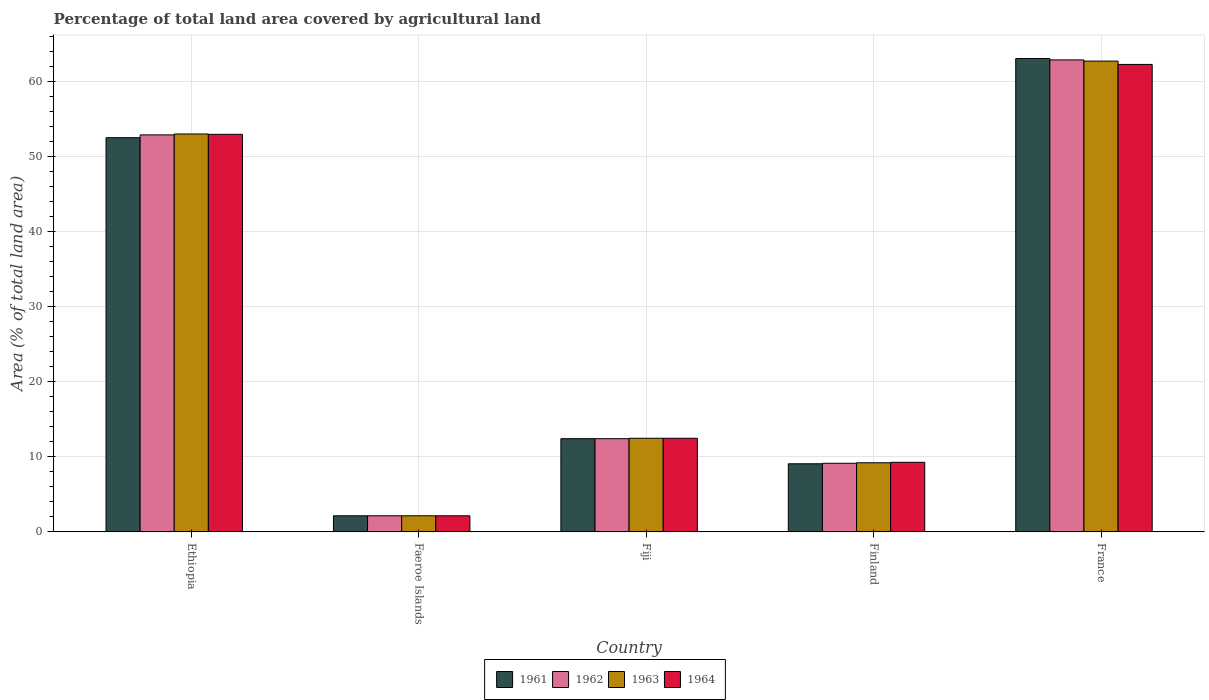How many different coloured bars are there?
Your response must be concise. 4. Are the number of bars per tick equal to the number of legend labels?
Provide a short and direct response. Yes. Are the number of bars on each tick of the X-axis equal?
Provide a short and direct response. Yes. How many bars are there on the 3rd tick from the right?
Provide a short and direct response. 4. What is the label of the 2nd group of bars from the left?
Make the answer very short. Faeroe Islands. What is the percentage of agricultural land in 1961 in Fiji?
Make the answer very short. 12.42. Across all countries, what is the maximum percentage of agricultural land in 1962?
Make the answer very short. 62.9. Across all countries, what is the minimum percentage of agricultural land in 1962?
Ensure brevity in your answer.  2.15. In which country was the percentage of agricultural land in 1963 minimum?
Give a very brief answer. Faeroe Islands. What is the total percentage of agricultural land in 1961 in the graph?
Your answer should be compact. 139.26. What is the difference between the percentage of agricultural land in 1963 in Faeroe Islands and that in Fiji?
Ensure brevity in your answer.  -10.33. What is the difference between the percentage of agricultural land in 1962 in Fiji and the percentage of agricultural land in 1961 in Faeroe Islands?
Give a very brief answer. 10.28. What is the average percentage of agricultural land in 1961 per country?
Ensure brevity in your answer.  27.85. What is the difference between the percentage of agricultural land of/in 1963 and percentage of agricultural land of/in 1964 in Fiji?
Provide a short and direct response. 0. In how many countries, is the percentage of agricultural land in 1963 greater than 46 %?
Provide a short and direct response. 2. What is the ratio of the percentage of agricultural land in 1962 in Faeroe Islands to that in Finland?
Provide a succinct answer. 0.24. Is the percentage of agricultural land in 1963 in Ethiopia less than that in France?
Offer a very short reply. Yes. What is the difference between the highest and the second highest percentage of agricultural land in 1961?
Keep it short and to the point. 40.11. What is the difference between the highest and the lowest percentage of agricultural land in 1964?
Your answer should be very brief. 60.14. In how many countries, is the percentage of agricultural land in 1964 greater than the average percentage of agricultural land in 1964 taken over all countries?
Keep it short and to the point. 2. Is the sum of the percentage of agricultural land in 1964 in Ethiopia and France greater than the maximum percentage of agricultural land in 1961 across all countries?
Offer a terse response. Yes. Is it the case that in every country, the sum of the percentage of agricultural land in 1963 and percentage of agricultural land in 1964 is greater than the sum of percentage of agricultural land in 1962 and percentage of agricultural land in 1961?
Give a very brief answer. No. Is it the case that in every country, the sum of the percentage of agricultural land in 1963 and percentage of agricultural land in 1961 is greater than the percentage of agricultural land in 1964?
Make the answer very short. Yes. How many bars are there?
Your answer should be very brief. 20. Are all the bars in the graph horizontal?
Provide a succinct answer. No. Does the graph contain any zero values?
Your response must be concise. No. How many legend labels are there?
Provide a succinct answer. 4. How are the legend labels stacked?
Provide a short and direct response. Horizontal. What is the title of the graph?
Provide a succinct answer. Percentage of total land area covered by agricultural land. Does "1987" appear as one of the legend labels in the graph?
Provide a short and direct response. No. What is the label or title of the Y-axis?
Offer a very short reply. Area (% of total land area). What is the Area (% of total land area) in 1961 in Ethiopia?
Offer a very short reply. 52.53. What is the Area (% of total land area) in 1962 in Ethiopia?
Your answer should be compact. 52.91. What is the Area (% of total land area) of 1963 in Ethiopia?
Offer a terse response. 53.02. What is the Area (% of total land area) in 1964 in Ethiopia?
Provide a succinct answer. 52.98. What is the Area (% of total land area) in 1961 in Faeroe Islands?
Your response must be concise. 2.15. What is the Area (% of total land area) in 1962 in Faeroe Islands?
Ensure brevity in your answer.  2.15. What is the Area (% of total land area) of 1963 in Faeroe Islands?
Provide a succinct answer. 2.15. What is the Area (% of total land area) of 1964 in Faeroe Islands?
Provide a short and direct response. 2.15. What is the Area (% of total land area) of 1961 in Fiji?
Provide a short and direct response. 12.42. What is the Area (% of total land area) of 1962 in Fiji?
Provide a succinct answer. 12.42. What is the Area (% of total land area) in 1963 in Fiji?
Ensure brevity in your answer.  12.48. What is the Area (% of total land area) in 1964 in Fiji?
Provide a short and direct response. 12.48. What is the Area (% of total land area) in 1961 in Finland?
Give a very brief answer. 9.08. What is the Area (% of total land area) of 1962 in Finland?
Make the answer very short. 9.14. What is the Area (% of total land area) in 1963 in Finland?
Keep it short and to the point. 9.21. What is the Area (% of total land area) of 1964 in Finland?
Give a very brief answer. 9.28. What is the Area (% of total land area) of 1961 in France?
Your answer should be compact. 63.08. What is the Area (% of total land area) of 1962 in France?
Give a very brief answer. 62.9. What is the Area (% of total land area) in 1963 in France?
Ensure brevity in your answer.  62.74. What is the Area (% of total land area) of 1964 in France?
Provide a succinct answer. 62.29. Across all countries, what is the maximum Area (% of total land area) of 1961?
Give a very brief answer. 63.08. Across all countries, what is the maximum Area (% of total land area) of 1962?
Provide a succinct answer. 62.9. Across all countries, what is the maximum Area (% of total land area) in 1963?
Give a very brief answer. 62.74. Across all countries, what is the maximum Area (% of total land area) of 1964?
Keep it short and to the point. 62.29. Across all countries, what is the minimum Area (% of total land area) in 1961?
Ensure brevity in your answer.  2.15. Across all countries, what is the minimum Area (% of total land area) in 1962?
Provide a succinct answer. 2.15. Across all countries, what is the minimum Area (% of total land area) of 1963?
Offer a terse response. 2.15. Across all countries, what is the minimum Area (% of total land area) of 1964?
Ensure brevity in your answer.  2.15. What is the total Area (% of total land area) of 1961 in the graph?
Offer a terse response. 139.26. What is the total Area (% of total land area) in 1962 in the graph?
Provide a succinct answer. 139.52. What is the total Area (% of total land area) of 1963 in the graph?
Provide a short and direct response. 139.61. What is the total Area (% of total land area) in 1964 in the graph?
Ensure brevity in your answer.  139.18. What is the difference between the Area (% of total land area) of 1961 in Ethiopia and that in Faeroe Islands?
Provide a succinct answer. 50.38. What is the difference between the Area (% of total land area) of 1962 in Ethiopia and that in Faeroe Islands?
Give a very brief answer. 50.76. What is the difference between the Area (% of total land area) of 1963 in Ethiopia and that in Faeroe Islands?
Give a very brief answer. 50.88. What is the difference between the Area (% of total land area) of 1964 in Ethiopia and that in Faeroe Islands?
Give a very brief answer. 50.83. What is the difference between the Area (% of total land area) of 1961 in Ethiopia and that in Fiji?
Give a very brief answer. 40.11. What is the difference between the Area (% of total land area) of 1962 in Ethiopia and that in Fiji?
Provide a succinct answer. 40.48. What is the difference between the Area (% of total land area) in 1963 in Ethiopia and that in Fiji?
Keep it short and to the point. 40.55. What is the difference between the Area (% of total land area) in 1964 in Ethiopia and that in Fiji?
Provide a succinct answer. 40.5. What is the difference between the Area (% of total land area) in 1961 in Ethiopia and that in Finland?
Give a very brief answer. 43.45. What is the difference between the Area (% of total land area) of 1962 in Ethiopia and that in Finland?
Your answer should be compact. 43.76. What is the difference between the Area (% of total land area) in 1963 in Ethiopia and that in Finland?
Ensure brevity in your answer.  43.81. What is the difference between the Area (% of total land area) in 1964 in Ethiopia and that in Finland?
Make the answer very short. 43.7. What is the difference between the Area (% of total land area) in 1961 in Ethiopia and that in France?
Keep it short and to the point. -10.55. What is the difference between the Area (% of total land area) of 1962 in Ethiopia and that in France?
Provide a short and direct response. -9.99. What is the difference between the Area (% of total land area) in 1963 in Ethiopia and that in France?
Your response must be concise. -9.71. What is the difference between the Area (% of total land area) in 1964 in Ethiopia and that in France?
Offer a terse response. -9.31. What is the difference between the Area (% of total land area) in 1961 in Faeroe Islands and that in Fiji?
Keep it short and to the point. -10.28. What is the difference between the Area (% of total land area) in 1962 in Faeroe Islands and that in Fiji?
Provide a succinct answer. -10.28. What is the difference between the Area (% of total land area) in 1963 in Faeroe Islands and that in Fiji?
Your response must be concise. -10.33. What is the difference between the Area (% of total land area) in 1964 in Faeroe Islands and that in Fiji?
Make the answer very short. -10.33. What is the difference between the Area (% of total land area) of 1961 in Faeroe Islands and that in Finland?
Provide a succinct answer. -6.93. What is the difference between the Area (% of total land area) in 1962 in Faeroe Islands and that in Finland?
Make the answer very short. -6.99. What is the difference between the Area (% of total land area) of 1963 in Faeroe Islands and that in Finland?
Offer a terse response. -7.07. What is the difference between the Area (% of total land area) in 1964 in Faeroe Islands and that in Finland?
Ensure brevity in your answer.  -7.13. What is the difference between the Area (% of total land area) of 1961 in Faeroe Islands and that in France?
Provide a short and direct response. -60.93. What is the difference between the Area (% of total land area) of 1962 in Faeroe Islands and that in France?
Offer a terse response. -60.75. What is the difference between the Area (% of total land area) in 1963 in Faeroe Islands and that in France?
Keep it short and to the point. -60.59. What is the difference between the Area (% of total land area) of 1964 in Faeroe Islands and that in France?
Keep it short and to the point. -60.14. What is the difference between the Area (% of total land area) in 1961 in Fiji and that in Finland?
Offer a terse response. 3.34. What is the difference between the Area (% of total land area) of 1962 in Fiji and that in Finland?
Offer a very short reply. 3.28. What is the difference between the Area (% of total land area) in 1963 in Fiji and that in Finland?
Provide a short and direct response. 3.27. What is the difference between the Area (% of total land area) of 1964 in Fiji and that in Finland?
Ensure brevity in your answer.  3.2. What is the difference between the Area (% of total land area) of 1961 in Fiji and that in France?
Your answer should be very brief. -50.65. What is the difference between the Area (% of total land area) in 1962 in Fiji and that in France?
Your answer should be compact. -50.47. What is the difference between the Area (% of total land area) of 1963 in Fiji and that in France?
Keep it short and to the point. -50.26. What is the difference between the Area (% of total land area) in 1964 in Fiji and that in France?
Ensure brevity in your answer.  -49.81. What is the difference between the Area (% of total land area) in 1961 in Finland and that in France?
Make the answer very short. -54. What is the difference between the Area (% of total land area) of 1962 in Finland and that in France?
Provide a succinct answer. -53.75. What is the difference between the Area (% of total land area) of 1963 in Finland and that in France?
Your answer should be very brief. -53.53. What is the difference between the Area (% of total land area) of 1964 in Finland and that in France?
Provide a short and direct response. -53.02. What is the difference between the Area (% of total land area) in 1961 in Ethiopia and the Area (% of total land area) in 1962 in Faeroe Islands?
Your answer should be very brief. 50.38. What is the difference between the Area (% of total land area) of 1961 in Ethiopia and the Area (% of total land area) of 1963 in Faeroe Islands?
Give a very brief answer. 50.38. What is the difference between the Area (% of total land area) in 1961 in Ethiopia and the Area (% of total land area) in 1964 in Faeroe Islands?
Ensure brevity in your answer.  50.38. What is the difference between the Area (% of total land area) of 1962 in Ethiopia and the Area (% of total land area) of 1963 in Faeroe Islands?
Keep it short and to the point. 50.76. What is the difference between the Area (% of total land area) of 1962 in Ethiopia and the Area (% of total land area) of 1964 in Faeroe Islands?
Ensure brevity in your answer.  50.76. What is the difference between the Area (% of total land area) in 1963 in Ethiopia and the Area (% of total land area) in 1964 in Faeroe Islands?
Keep it short and to the point. 50.88. What is the difference between the Area (% of total land area) of 1961 in Ethiopia and the Area (% of total land area) of 1962 in Fiji?
Give a very brief answer. 40.11. What is the difference between the Area (% of total land area) of 1961 in Ethiopia and the Area (% of total land area) of 1963 in Fiji?
Make the answer very short. 40.05. What is the difference between the Area (% of total land area) of 1961 in Ethiopia and the Area (% of total land area) of 1964 in Fiji?
Give a very brief answer. 40.05. What is the difference between the Area (% of total land area) in 1962 in Ethiopia and the Area (% of total land area) in 1963 in Fiji?
Make the answer very short. 40.43. What is the difference between the Area (% of total land area) of 1962 in Ethiopia and the Area (% of total land area) of 1964 in Fiji?
Offer a terse response. 40.43. What is the difference between the Area (% of total land area) of 1963 in Ethiopia and the Area (% of total land area) of 1964 in Fiji?
Give a very brief answer. 40.55. What is the difference between the Area (% of total land area) in 1961 in Ethiopia and the Area (% of total land area) in 1962 in Finland?
Give a very brief answer. 43.39. What is the difference between the Area (% of total land area) of 1961 in Ethiopia and the Area (% of total land area) of 1963 in Finland?
Offer a terse response. 43.32. What is the difference between the Area (% of total land area) in 1961 in Ethiopia and the Area (% of total land area) in 1964 in Finland?
Offer a very short reply. 43.25. What is the difference between the Area (% of total land area) in 1962 in Ethiopia and the Area (% of total land area) in 1963 in Finland?
Provide a succinct answer. 43.69. What is the difference between the Area (% of total land area) of 1962 in Ethiopia and the Area (% of total land area) of 1964 in Finland?
Make the answer very short. 43.63. What is the difference between the Area (% of total land area) in 1963 in Ethiopia and the Area (% of total land area) in 1964 in Finland?
Make the answer very short. 43.75. What is the difference between the Area (% of total land area) of 1961 in Ethiopia and the Area (% of total land area) of 1962 in France?
Ensure brevity in your answer.  -10.37. What is the difference between the Area (% of total land area) of 1961 in Ethiopia and the Area (% of total land area) of 1963 in France?
Give a very brief answer. -10.21. What is the difference between the Area (% of total land area) in 1961 in Ethiopia and the Area (% of total land area) in 1964 in France?
Provide a succinct answer. -9.76. What is the difference between the Area (% of total land area) in 1962 in Ethiopia and the Area (% of total land area) in 1963 in France?
Offer a very short reply. -9.83. What is the difference between the Area (% of total land area) in 1962 in Ethiopia and the Area (% of total land area) in 1964 in France?
Offer a terse response. -9.39. What is the difference between the Area (% of total land area) of 1963 in Ethiopia and the Area (% of total land area) of 1964 in France?
Your answer should be compact. -9.27. What is the difference between the Area (% of total land area) in 1961 in Faeroe Islands and the Area (% of total land area) in 1962 in Fiji?
Ensure brevity in your answer.  -10.28. What is the difference between the Area (% of total land area) in 1961 in Faeroe Islands and the Area (% of total land area) in 1963 in Fiji?
Offer a terse response. -10.33. What is the difference between the Area (% of total land area) in 1961 in Faeroe Islands and the Area (% of total land area) in 1964 in Fiji?
Your answer should be compact. -10.33. What is the difference between the Area (% of total land area) of 1962 in Faeroe Islands and the Area (% of total land area) of 1963 in Fiji?
Your answer should be very brief. -10.33. What is the difference between the Area (% of total land area) in 1962 in Faeroe Islands and the Area (% of total land area) in 1964 in Fiji?
Offer a very short reply. -10.33. What is the difference between the Area (% of total land area) in 1963 in Faeroe Islands and the Area (% of total land area) in 1964 in Fiji?
Your response must be concise. -10.33. What is the difference between the Area (% of total land area) of 1961 in Faeroe Islands and the Area (% of total land area) of 1962 in Finland?
Provide a short and direct response. -6.99. What is the difference between the Area (% of total land area) of 1961 in Faeroe Islands and the Area (% of total land area) of 1963 in Finland?
Offer a terse response. -7.07. What is the difference between the Area (% of total land area) in 1961 in Faeroe Islands and the Area (% of total land area) in 1964 in Finland?
Make the answer very short. -7.13. What is the difference between the Area (% of total land area) of 1962 in Faeroe Islands and the Area (% of total land area) of 1963 in Finland?
Provide a short and direct response. -7.07. What is the difference between the Area (% of total land area) in 1962 in Faeroe Islands and the Area (% of total land area) in 1964 in Finland?
Your response must be concise. -7.13. What is the difference between the Area (% of total land area) of 1963 in Faeroe Islands and the Area (% of total land area) of 1964 in Finland?
Make the answer very short. -7.13. What is the difference between the Area (% of total land area) in 1961 in Faeroe Islands and the Area (% of total land area) in 1962 in France?
Offer a very short reply. -60.75. What is the difference between the Area (% of total land area) in 1961 in Faeroe Islands and the Area (% of total land area) in 1963 in France?
Offer a very short reply. -60.59. What is the difference between the Area (% of total land area) in 1961 in Faeroe Islands and the Area (% of total land area) in 1964 in France?
Provide a succinct answer. -60.14. What is the difference between the Area (% of total land area) in 1962 in Faeroe Islands and the Area (% of total land area) in 1963 in France?
Offer a terse response. -60.59. What is the difference between the Area (% of total land area) of 1962 in Faeroe Islands and the Area (% of total land area) of 1964 in France?
Offer a terse response. -60.14. What is the difference between the Area (% of total land area) of 1963 in Faeroe Islands and the Area (% of total land area) of 1964 in France?
Provide a short and direct response. -60.14. What is the difference between the Area (% of total land area) in 1961 in Fiji and the Area (% of total land area) in 1962 in Finland?
Your response must be concise. 3.28. What is the difference between the Area (% of total land area) in 1961 in Fiji and the Area (% of total land area) in 1963 in Finland?
Provide a succinct answer. 3.21. What is the difference between the Area (% of total land area) of 1961 in Fiji and the Area (% of total land area) of 1964 in Finland?
Give a very brief answer. 3.15. What is the difference between the Area (% of total land area) in 1962 in Fiji and the Area (% of total land area) in 1963 in Finland?
Keep it short and to the point. 3.21. What is the difference between the Area (% of total land area) in 1962 in Fiji and the Area (% of total land area) in 1964 in Finland?
Keep it short and to the point. 3.15. What is the difference between the Area (% of total land area) of 1963 in Fiji and the Area (% of total land area) of 1964 in Finland?
Provide a short and direct response. 3.2. What is the difference between the Area (% of total land area) of 1961 in Fiji and the Area (% of total land area) of 1962 in France?
Provide a short and direct response. -50.47. What is the difference between the Area (% of total land area) of 1961 in Fiji and the Area (% of total land area) of 1963 in France?
Your answer should be very brief. -50.31. What is the difference between the Area (% of total land area) of 1961 in Fiji and the Area (% of total land area) of 1964 in France?
Offer a very short reply. -49.87. What is the difference between the Area (% of total land area) in 1962 in Fiji and the Area (% of total land area) in 1963 in France?
Keep it short and to the point. -50.31. What is the difference between the Area (% of total land area) of 1962 in Fiji and the Area (% of total land area) of 1964 in France?
Give a very brief answer. -49.87. What is the difference between the Area (% of total land area) in 1963 in Fiji and the Area (% of total land area) in 1964 in France?
Give a very brief answer. -49.81. What is the difference between the Area (% of total land area) in 1961 in Finland and the Area (% of total land area) in 1962 in France?
Ensure brevity in your answer.  -53.82. What is the difference between the Area (% of total land area) of 1961 in Finland and the Area (% of total land area) of 1963 in France?
Your response must be concise. -53.66. What is the difference between the Area (% of total land area) of 1961 in Finland and the Area (% of total land area) of 1964 in France?
Provide a short and direct response. -53.21. What is the difference between the Area (% of total land area) in 1962 in Finland and the Area (% of total land area) in 1963 in France?
Your answer should be very brief. -53.6. What is the difference between the Area (% of total land area) in 1962 in Finland and the Area (% of total land area) in 1964 in France?
Offer a terse response. -53.15. What is the difference between the Area (% of total land area) of 1963 in Finland and the Area (% of total land area) of 1964 in France?
Ensure brevity in your answer.  -53.08. What is the average Area (% of total land area) of 1961 per country?
Provide a short and direct response. 27.85. What is the average Area (% of total land area) of 1962 per country?
Ensure brevity in your answer.  27.9. What is the average Area (% of total land area) in 1963 per country?
Offer a terse response. 27.92. What is the average Area (% of total land area) in 1964 per country?
Make the answer very short. 27.84. What is the difference between the Area (% of total land area) in 1961 and Area (% of total land area) in 1962 in Ethiopia?
Offer a very short reply. -0.38. What is the difference between the Area (% of total land area) of 1961 and Area (% of total land area) of 1963 in Ethiopia?
Your response must be concise. -0.49. What is the difference between the Area (% of total land area) in 1961 and Area (% of total land area) in 1964 in Ethiopia?
Provide a short and direct response. -0.45. What is the difference between the Area (% of total land area) in 1962 and Area (% of total land area) in 1963 in Ethiopia?
Your response must be concise. -0.12. What is the difference between the Area (% of total land area) in 1962 and Area (% of total land area) in 1964 in Ethiopia?
Ensure brevity in your answer.  -0.07. What is the difference between the Area (% of total land area) of 1963 and Area (% of total land area) of 1964 in Ethiopia?
Offer a very short reply. 0.05. What is the difference between the Area (% of total land area) in 1961 and Area (% of total land area) in 1962 in Faeroe Islands?
Provide a succinct answer. 0. What is the difference between the Area (% of total land area) in 1961 and Area (% of total land area) in 1964 in Faeroe Islands?
Your response must be concise. 0. What is the difference between the Area (% of total land area) of 1963 and Area (% of total land area) of 1964 in Faeroe Islands?
Your answer should be compact. 0. What is the difference between the Area (% of total land area) in 1961 and Area (% of total land area) in 1962 in Fiji?
Offer a terse response. 0. What is the difference between the Area (% of total land area) of 1961 and Area (% of total land area) of 1963 in Fiji?
Provide a short and direct response. -0.05. What is the difference between the Area (% of total land area) of 1961 and Area (% of total land area) of 1964 in Fiji?
Give a very brief answer. -0.05. What is the difference between the Area (% of total land area) of 1962 and Area (% of total land area) of 1963 in Fiji?
Offer a very short reply. -0.05. What is the difference between the Area (% of total land area) in 1962 and Area (% of total land area) in 1964 in Fiji?
Provide a succinct answer. -0.05. What is the difference between the Area (% of total land area) in 1961 and Area (% of total land area) in 1962 in Finland?
Your answer should be very brief. -0.06. What is the difference between the Area (% of total land area) of 1961 and Area (% of total land area) of 1963 in Finland?
Your response must be concise. -0.13. What is the difference between the Area (% of total land area) of 1961 and Area (% of total land area) of 1964 in Finland?
Offer a very short reply. -0.2. What is the difference between the Area (% of total land area) of 1962 and Area (% of total land area) of 1963 in Finland?
Your answer should be very brief. -0.07. What is the difference between the Area (% of total land area) in 1962 and Area (% of total land area) in 1964 in Finland?
Keep it short and to the point. -0.13. What is the difference between the Area (% of total land area) in 1963 and Area (% of total land area) in 1964 in Finland?
Offer a very short reply. -0.06. What is the difference between the Area (% of total land area) in 1961 and Area (% of total land area) in 1962 in France?
Offer a very short reply. 0.18. What is the difference between the Area (% of total land area) of 1961 and Area (% of total land area) of 1963 in France?
Offer a very short reply. 0.34. What is the difference between the Area (% of total land area) in 1961 and Area (% of total land area) in 1964 in France?
Keep it short and to the point. 0.79. What is the difference between the Area (% of total land area) in 1962 and Area (% of total land area) in 1963 in France?
Ensure brevity in your answer.  0.16. What is the difference between the Area (% of total land area) in 1962 and Area (% of total land area) in 1964 in France?
Your response must be concise. 0.6. What is the difference between the Area (% of total land area) in 1963 and Area (% of total land area) in 1964 in France?
Make the answer very short. 0.45. What is the ratio of the Area (% of total land area) in 1961 in Ethiopia to that in Faeroe Islands?
Provide a succinct answer. 24.44. What is the ratio of the Area (% of total land area) in 1962 in Ethiopia to that in Faeroe Islands?
Give a very brief answer. 24.62. What is the ratio of the Area (% of total land area) of 1963 in Ethiopia to that in Faeroe Islands?
Make the answer very short. 24.67. What is the ratio of the Area (% of total land area) in 1964 in Ethiopia to that in Faeroe Islands?
Your answer should be compact. 24.65. What is the ratio of the Area (% of total land area) in 1961 in Ethiopia to that in Fiji?
Offer a very short reply. 4.23. What is the ratio of the Area (% of total land area) of 1962 in Ethiopia to that in Fiji?
Your answer should be very brief. 4.26. What is the ratio of the Area (% of total land area) of 1963 in Ethiopia to that in Fiji?
Ensure brevity in your answer.  4.25. What is the ratio of the Area (% of total land area) of 1964 in Ethiopia to that in Fiji?
Make the answer very short. 4.25. What is the ratio of the Area (% of total land area) of 1961 in Ethiopia to that in Finland?
Provide a short and direct response. 5.79. What is the ratio of the Area (% of total land area) in 1962 in Ethiopia to that in Finland?
Your answer should be compact. 5.79. What is the ratio of the Area (% of total land area) in 1963 in Ethiopia to that in Finland?
Provide a succinct answer. 5.75. What is the ratio of the Area (% of total land area) in 1964 in Ethiopia to that in Finland?
Provide a succinct answer. 5.71. What is the ratio of the Area (% of total land area) of 1961 in Ethiopia to that in France?
Provide a short and direct response. 0.83. What is the ratio of the Area (% of total land area) in 1962 in Ethiopia to that in France?
Your response must be concise. 0.84. What is the ratio of the Area (% of total land area) in 1963 in Ethiopia to that in France?
Provide a succinct answer. 0.85. What is the ratio of the Area (% of total land area) in 1964 in Ethiopia to that in France?
Keep it short and to the point. 0.85. What is the ratio of the Area (% of total land area) in 1961 in Faeroe Islands to that in Fiji?
Offer a terse response. 0.17. What is the ratio of the Area (% of total land area) in 1962 in Faeroe Islands to that in Fiji?
Your response must be concise. 0.17. What is the ratio of the Area (% of total land area) in 1963 in Faeroe Islands to that in Fiji?
Ensure brevity in your answer.  0.17. What is the ratio of the Area (% of total land area) of 1964 in Faeroe Islands to that in Fiji?
Offer a very short reply. 0.17. What is the ratio of the Area (% of total land area) in 1961 in Faeroe Islands to that in Finland?
Make the answer very short. 0.24. What is the ratio of the Area (% of total land area) of 1962 in Faeroe Islands to that in Finland?
Ensure brevity in your answer.  0.23. What is the ratio of the Area (% of total land area) of 1963 in Faeroe Islands to that in Finland?
Keep it short and to the point. 0.23. What is the ratio of the Area (% of total land area) of 1964 in Faeroe Islands to that in Finland?
Offer a very short reply. 0.23. What is the ratio of the Area (% of total land area) of 1961 in Faeroe Islands to that in France?
Keep it short and to the point. 0.03. What is the ratio of the Area (% of total land area) of 1962 in Faeroe Islands to that in France?
Ensure brevity in your answer.  0.03. What is the ratio of the Area (% of total land area) in 1963 in Faeroe Islands to that in France?
Give a very brief answer. 0.03. What is the ratio of the Area (% of total land area) of 1964 in Faeroe Islands to that in France?
Offer a terse response. 0.03. What is the ratio of the Area (% of total land area) in 1961 in Fiji to that in Finland?
Make the answer very short. 1.37. What is the ratio of the Area (% of total land area) in 1962 in Fiji to that in Finland?
Provide a succinct answer. 1.36. What is the ratio of the Area (% of total land area) of 1963 in Fiji to that in Finland?
Your response must be concise. 1.35. What is the ratio of the Area (% of total land area) in 1964 in Fiji to that in Finland?
Offer a very short reply. 1.35. What is the ratio of the Area (% of total land area) of 1961 in Fiji to that in France?
Offer a terse response. 0.2. What is the ratio of the Area (% of total land area) of 1962 in Fiji to that in France?
Offer a very short reply. 0.2. What is the ratio of the Area (% of total land area) in 1963 in Fiji to that in France?
Offer a terse response. 0.2. What is the ratio of the Area (% of total land area) of 1964 in Fiji to that in France?
Offer a very short reply. 0.2. What is the ratio of the Area (% of total land area) in 1961 in Finland to that in France?
Offer a terse response. 0.14. What is the ratio of the Area (% of total land area) in 1962 in Finland to that in France?
Your response must be concise. 0.15. What is the ratio of the Area (% of total land area) of 1963 in Finland to that in France?
Your answer should be very brief. 0.15. What is the ratio of the Area (% of total land area) in 1964 in Finland to that in France?
Make the answer very short. 0.15. What is the difference between the highest and the second highest Area (% of total land area) of 1961?
Your response must be concise. 10.55. What is the difference between the highest and the second highest Area (% of total land area) of 1962?
Make the answer very short. 9.99. What is the difference between the highest and the second highest Area (% of total land area) of 1963?
Your answer should be very brief. 9.71. What is the difference between the highest and the second highest Area (% of total land area) in 1964?
Give a very brief answer. 9.31. What is the difference between the highest and the lowest Area (% of total land area) of 1961?
Your answer should be compact. 60.93. What is the difference between the highest and the lowest Area (% of total land area) in 1962?
Provide a succinct answer. 60.75. What is the difference between the highest and the lowest Area (% of total land area) of 1963?
Your answer should be compact. 60.59. What is the difference between the highest and the lowest Area (% of total land area) in 1964?
Your answer should be very brief. 60.14. 